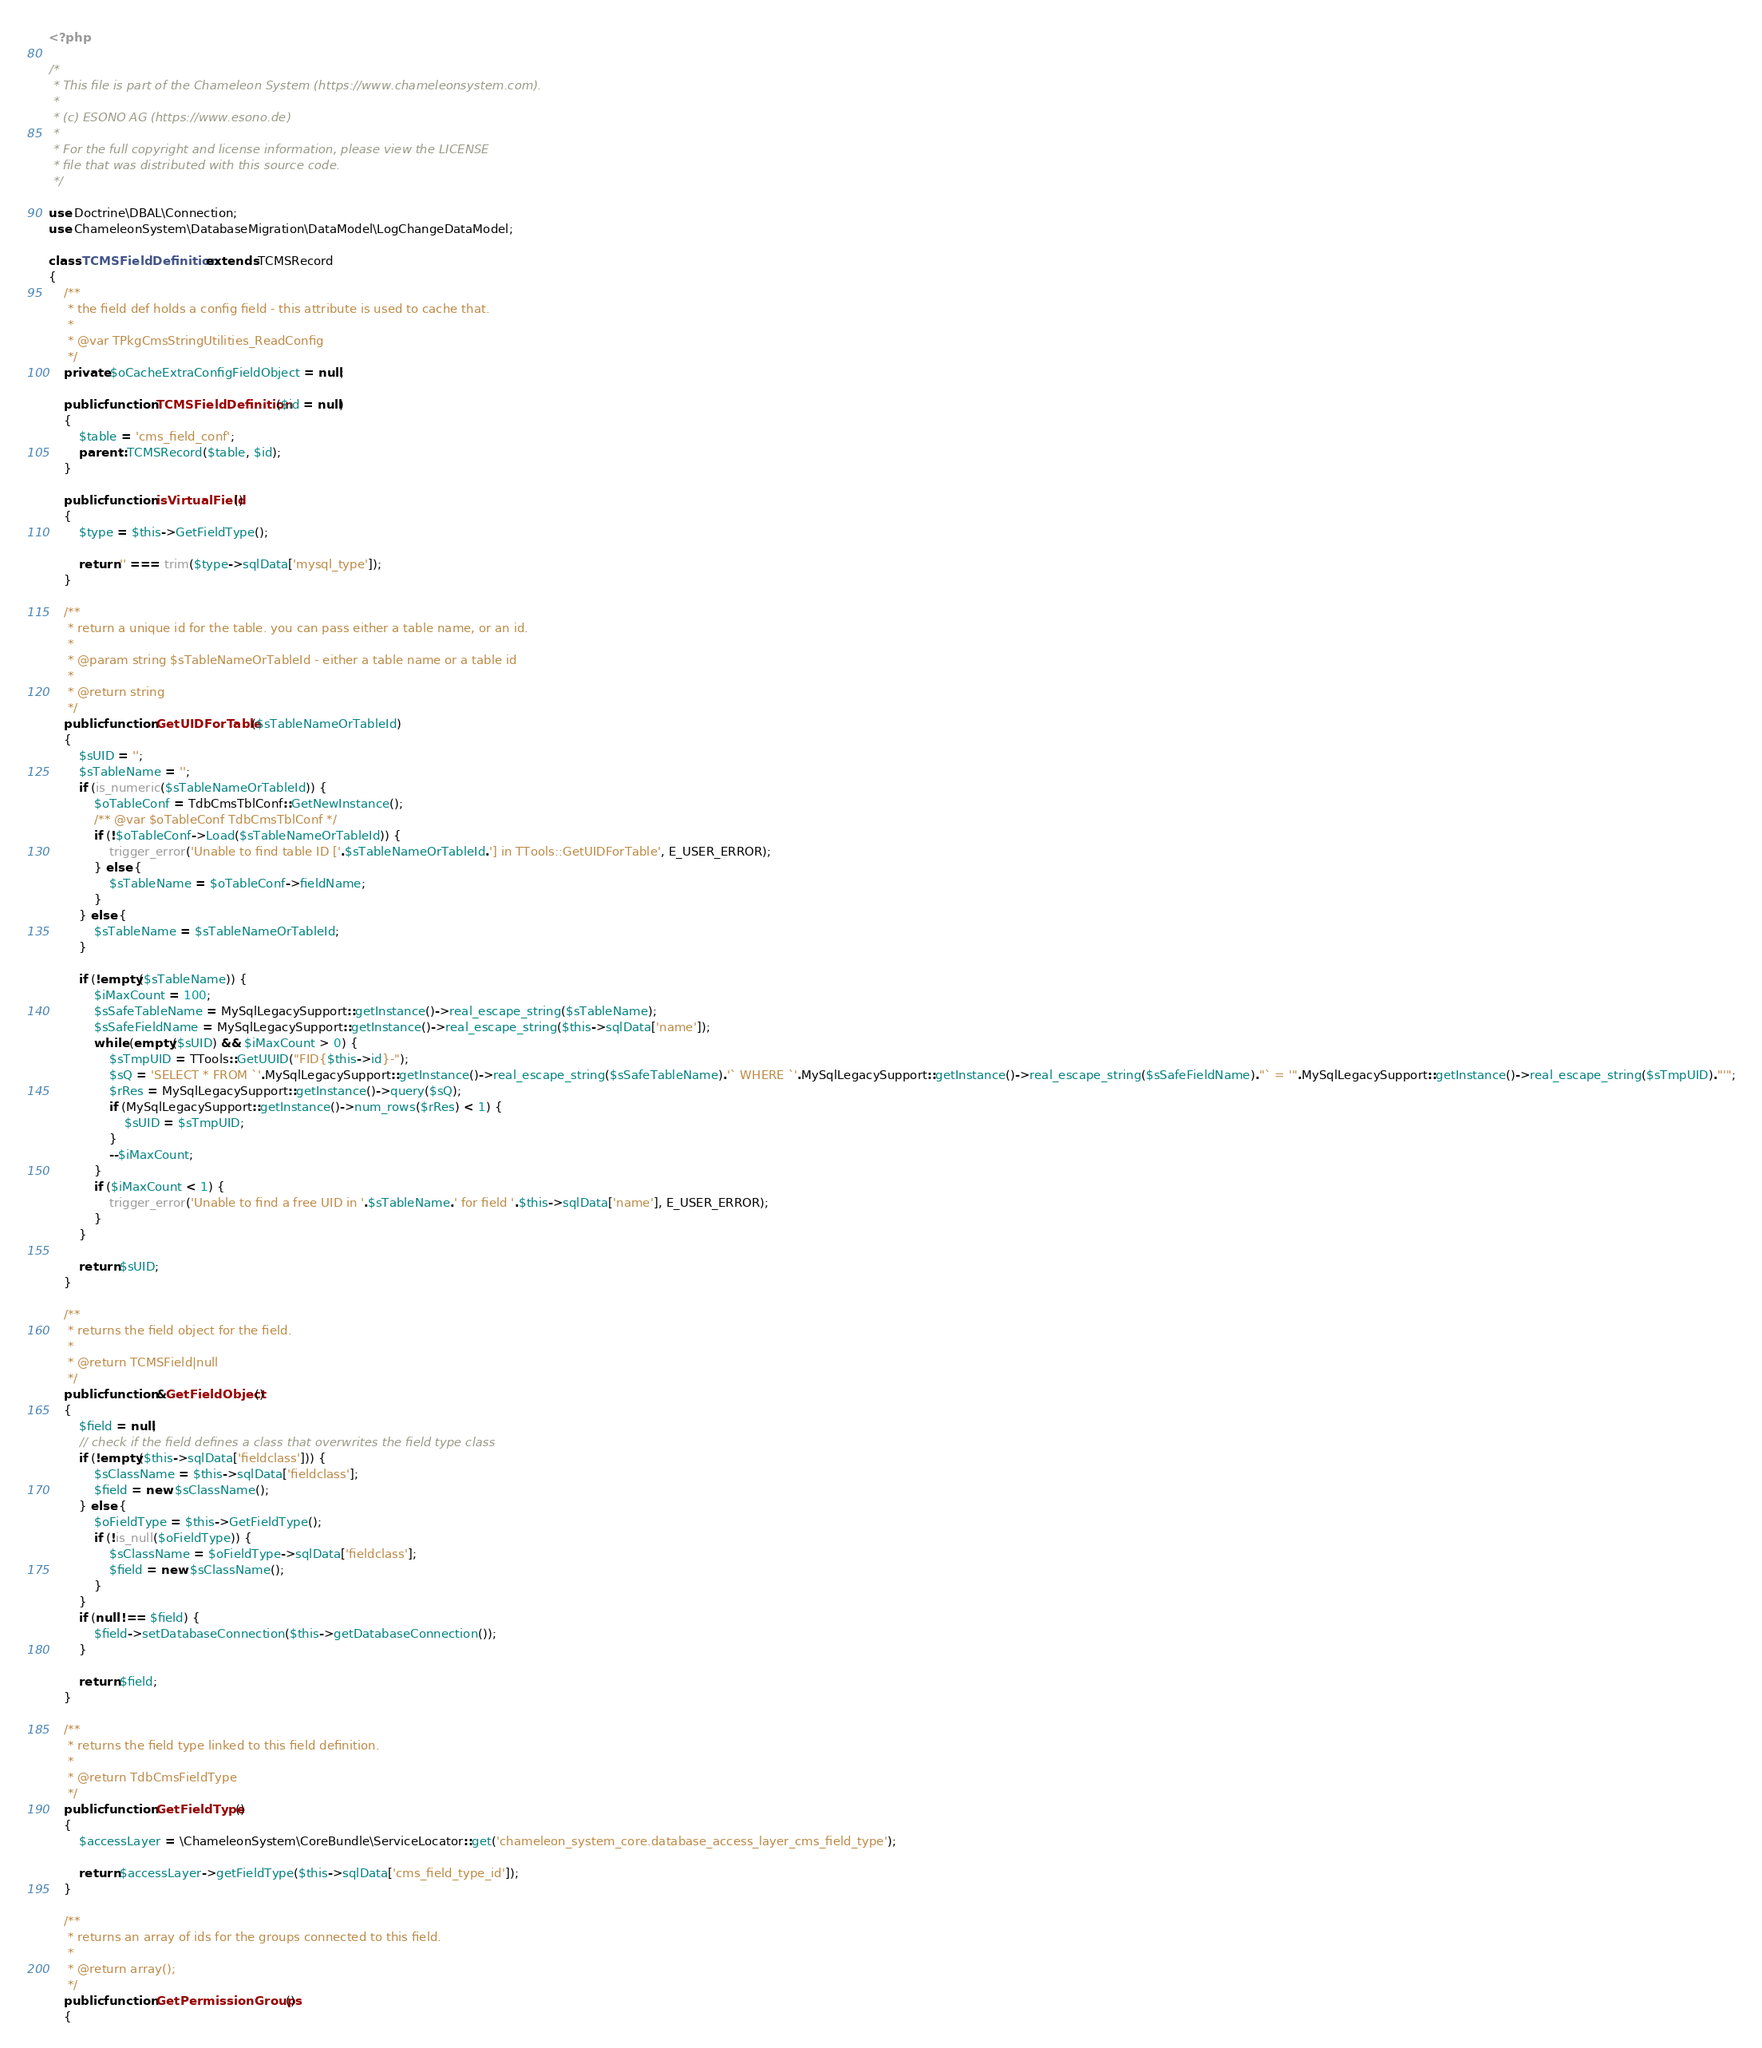<code> <loc_0><loc_0><loc_500><loc_500><_PHP_><?php

/*
 * This file is part of the Chameleon System (https://www.chameleonsystem.com).
 *
 * (c) ESONO AG (https://www.esono.de)
 *
 * For the full copyright and license information, please view the LICENSE
 * file that was distributed with this source code.
 */

use Doctrine\DBAL\Connection;
use ChameleonSystem\DatabaseMigration\DataModel\LogChangeDataModel;

class TCMSFieldDefinition extends TCMSRecord
{
    /**
     * the field def holds a config field - this attribute is used to cache that.
     *
     * @var TPkgCmsStringUtilities_ReadConfig
     */
    private $oCacheExtraConfigFieldObject = null;

    public function TCMSFieldDefinition($id = null)
    {
        $table = 'cms_field_conf';
        parent::TCMSRecord($table, $id);
    }

    public function isVirtualField()
    {
        $type = $this->GetFieldType();

        return '' === trim($type->sqlData['mysql_type']);
    }

    /**
     * return a unique id for the table. you can pass either a table name, or an id.
     *
     * @param string $sTableNameOrTableId - either a table name or a table id
     *
     * @return string
     */
    public function GetUIDForTable($sTableNameOrTableId)
    {
        $sUID = '';
        $sTableName = '';
        if (is_numeric($sTableNameOrTableId)) {
            $oTableConf = TdbCmsTblConf::GetNewInstance();
            /** @var $oTableConf TdbCmsTblConf */
            if (!$oTableConf->Load($sTableNameOrTableId)) {
                trigger_error('Unable to find table ID ['.$sTableNameOrTableId.'] in TTools::GetUIDForTable', E_USER_ERROR);
            } else {
                $sTableName = $oTableConf->fieldName;
            }
        } else {
            $sTableName = $sTableNameOrTableId;
        }

        if (!empty($sTableName)) {
            $iMaxCount = 100;
            $sSafeTableName = MySqlLegacySupport::getInstance()->real_escape_string($sTableName);
            $sSafeFieldName = MySqlLegacySupport::getInstance()->real_escape_string($this->sqlData['name']);
            while (empty($sUID) && $iMaxCount > 0) {
                $sTmpUID = TTools::GetUUID("FID{$this->id}-");
                $sQ = 'SELECT * FROM `'.MySqlLegacySupport::getInstance()->real_escape_string($sSafeTableName).'` WHERE `'.MySqlLegacySupport::getInstance()->real_escape_string($sSafeFieldName)."` = '".MySqlLegacySupport::getInstance()->real_escape_string($sTmpUID)."'";
                $rRes = MySqlLegacySupport::getInstance()->query($sQ);
                if (MySqlLegacySupport::getInstance()->num_rows($rRes) < 1) {
                    $sUID = $sTmpUID;
                }
                --$iMaxCount;
            }
            if ($iMaxCount < 1) {
                trigger_error('Unable to find a free UID in '.$sTableName.' for field '.$this->sqlData['name'], E_USER_ERROR);
            }
        }

        return $sUID;
    }

    /**
     * returns the field object for the field.
     *
     * @return TCMSField|null
     */
    public function &GetFieldObject()
    {
        $field = null;
        // check if the field defines a class that overwrites the field type class
        if (!empty($this->sqlData['fieldclass'])) {
            $sClassName = $this->sqlData['fieldclass'];
            $field = new $sClassName();
        } else {
            $oFieldType = $this->GetFieldType();
            if (!is_null($oFieldType)) {
                $sClassName = $oFieldType->sqlData['fieldclass'];
                $field = new $sClassName();
            }
        }
        if (null !== $field) {
            $field->setDatabaseConnection($this->getDatabaseConnection());
        }

        return $field;
    }

    /**
     * returns the field type linked to this field definition.
     *
     * @return TdbCmsFieldType
     */
    public function GetFieldType()
    {
        $accessLayer = \ChameleonSystem\CoreBundle\ServiceLocator::get('chameleon_system_core.database_access_layer_cms_field_type');

        return $accessLayer->getFieldType($this->sqlData['cms_field_type_id']);
    }

    /**
     * returns an array of ids for the groups connected to this field.
     *
     * @return array();
     */
    public function GetPermissionGroups()
    {</code> 